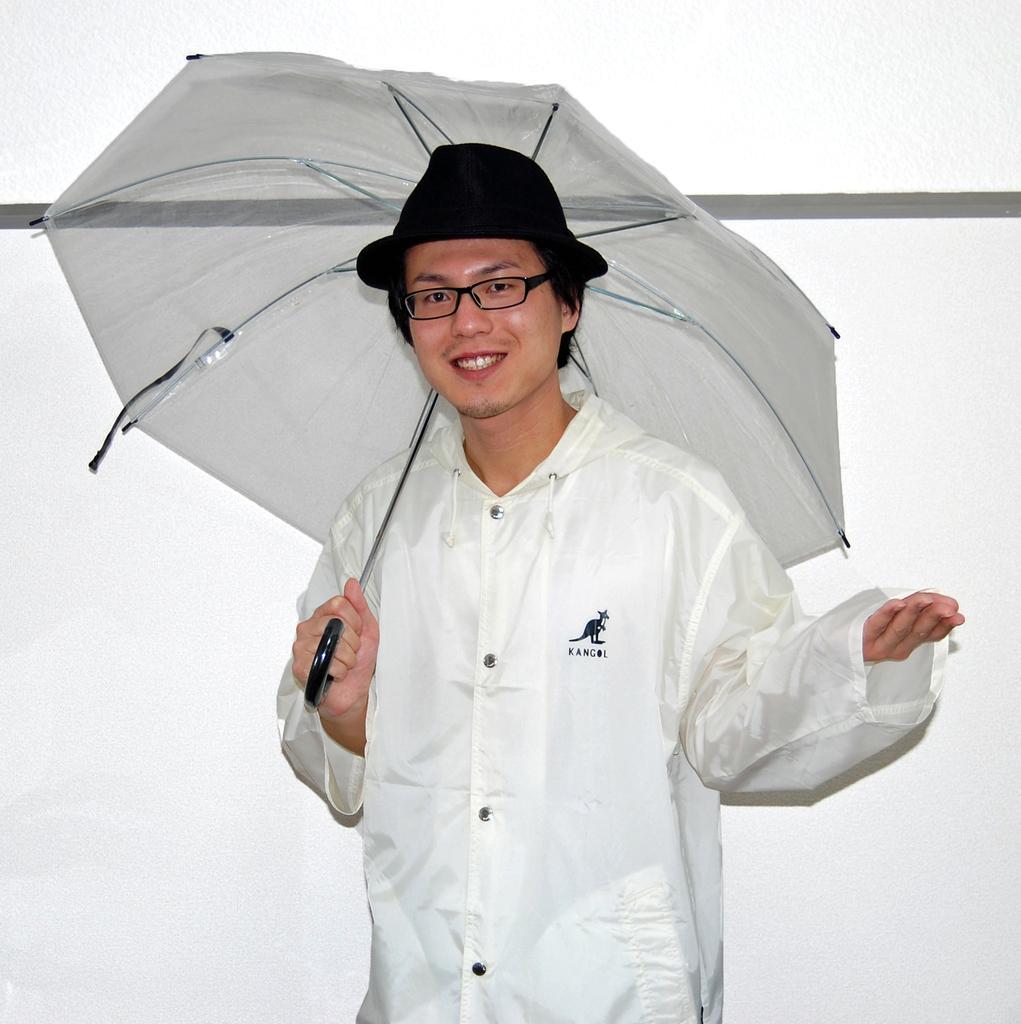Can you describe this image briefly? There is a man standing and smiling and holding a umbrella and wore spectacle and hat,behind this man we can see white wall. 